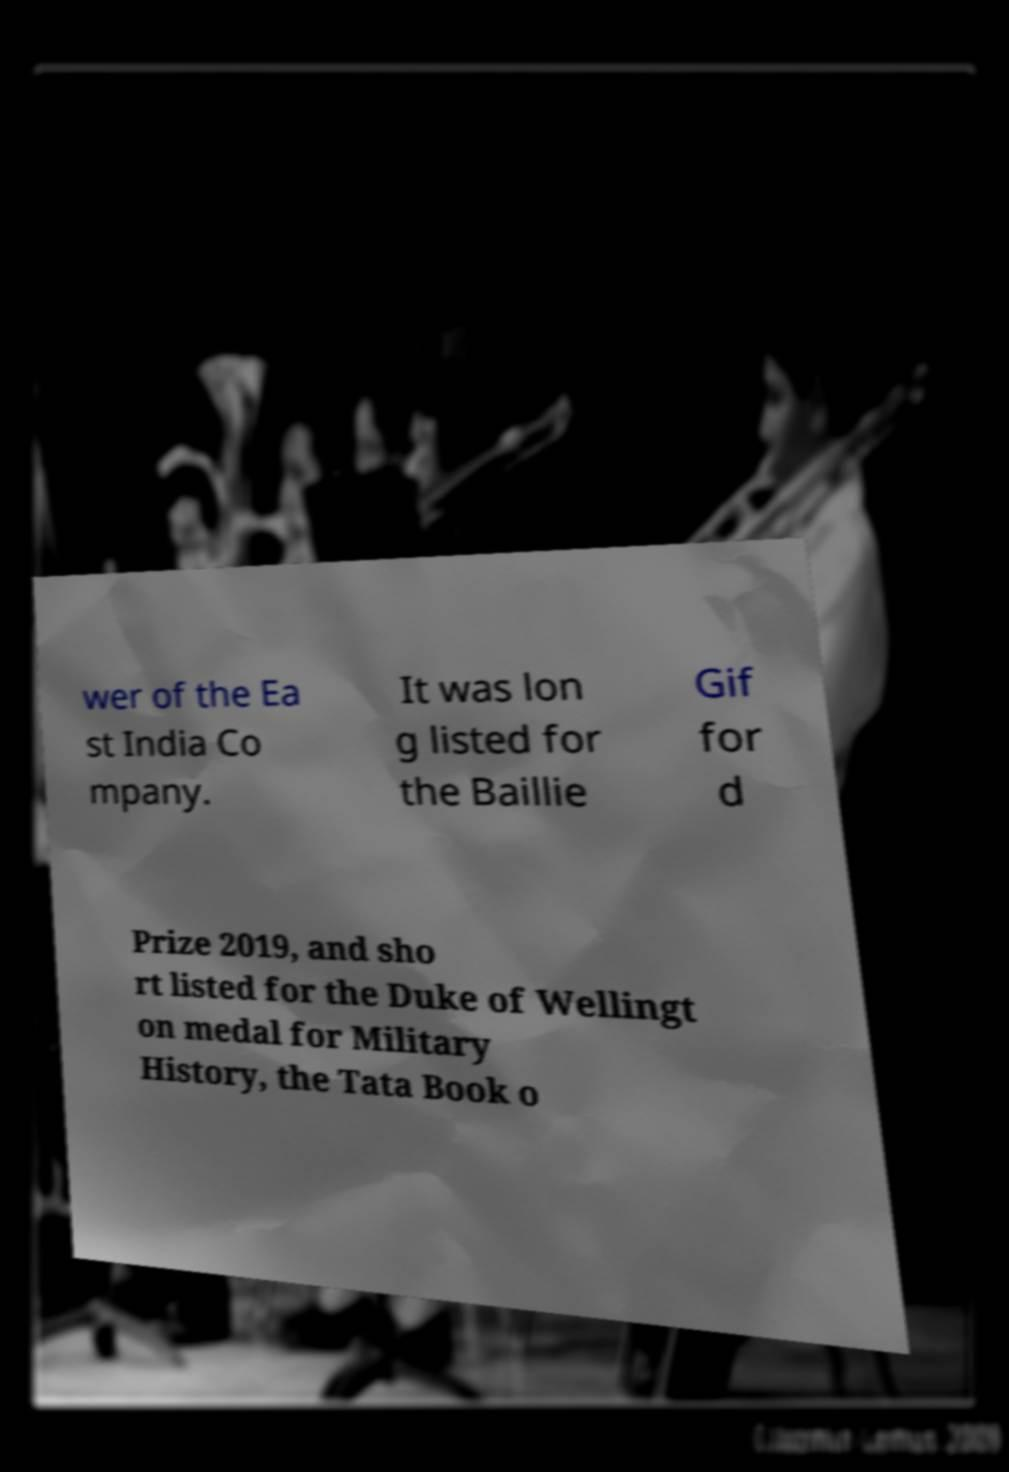For documentation purposes, I need the text within this image transcribed. Could you provide that? wer of the Ea st India Co mpany. It was lon g listed for the Baillie Gif for d Prize 2019, and sho rt listed for the Duke of Wellingt on medal for Military History, the Tata Book o 